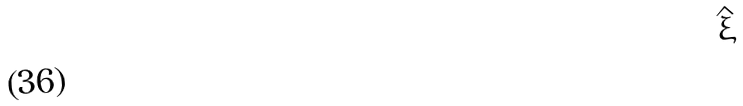Convert formula to latex. <formula><loc_0><loc_0><loc_500><loc_500>\hat { \xi }</formula> 